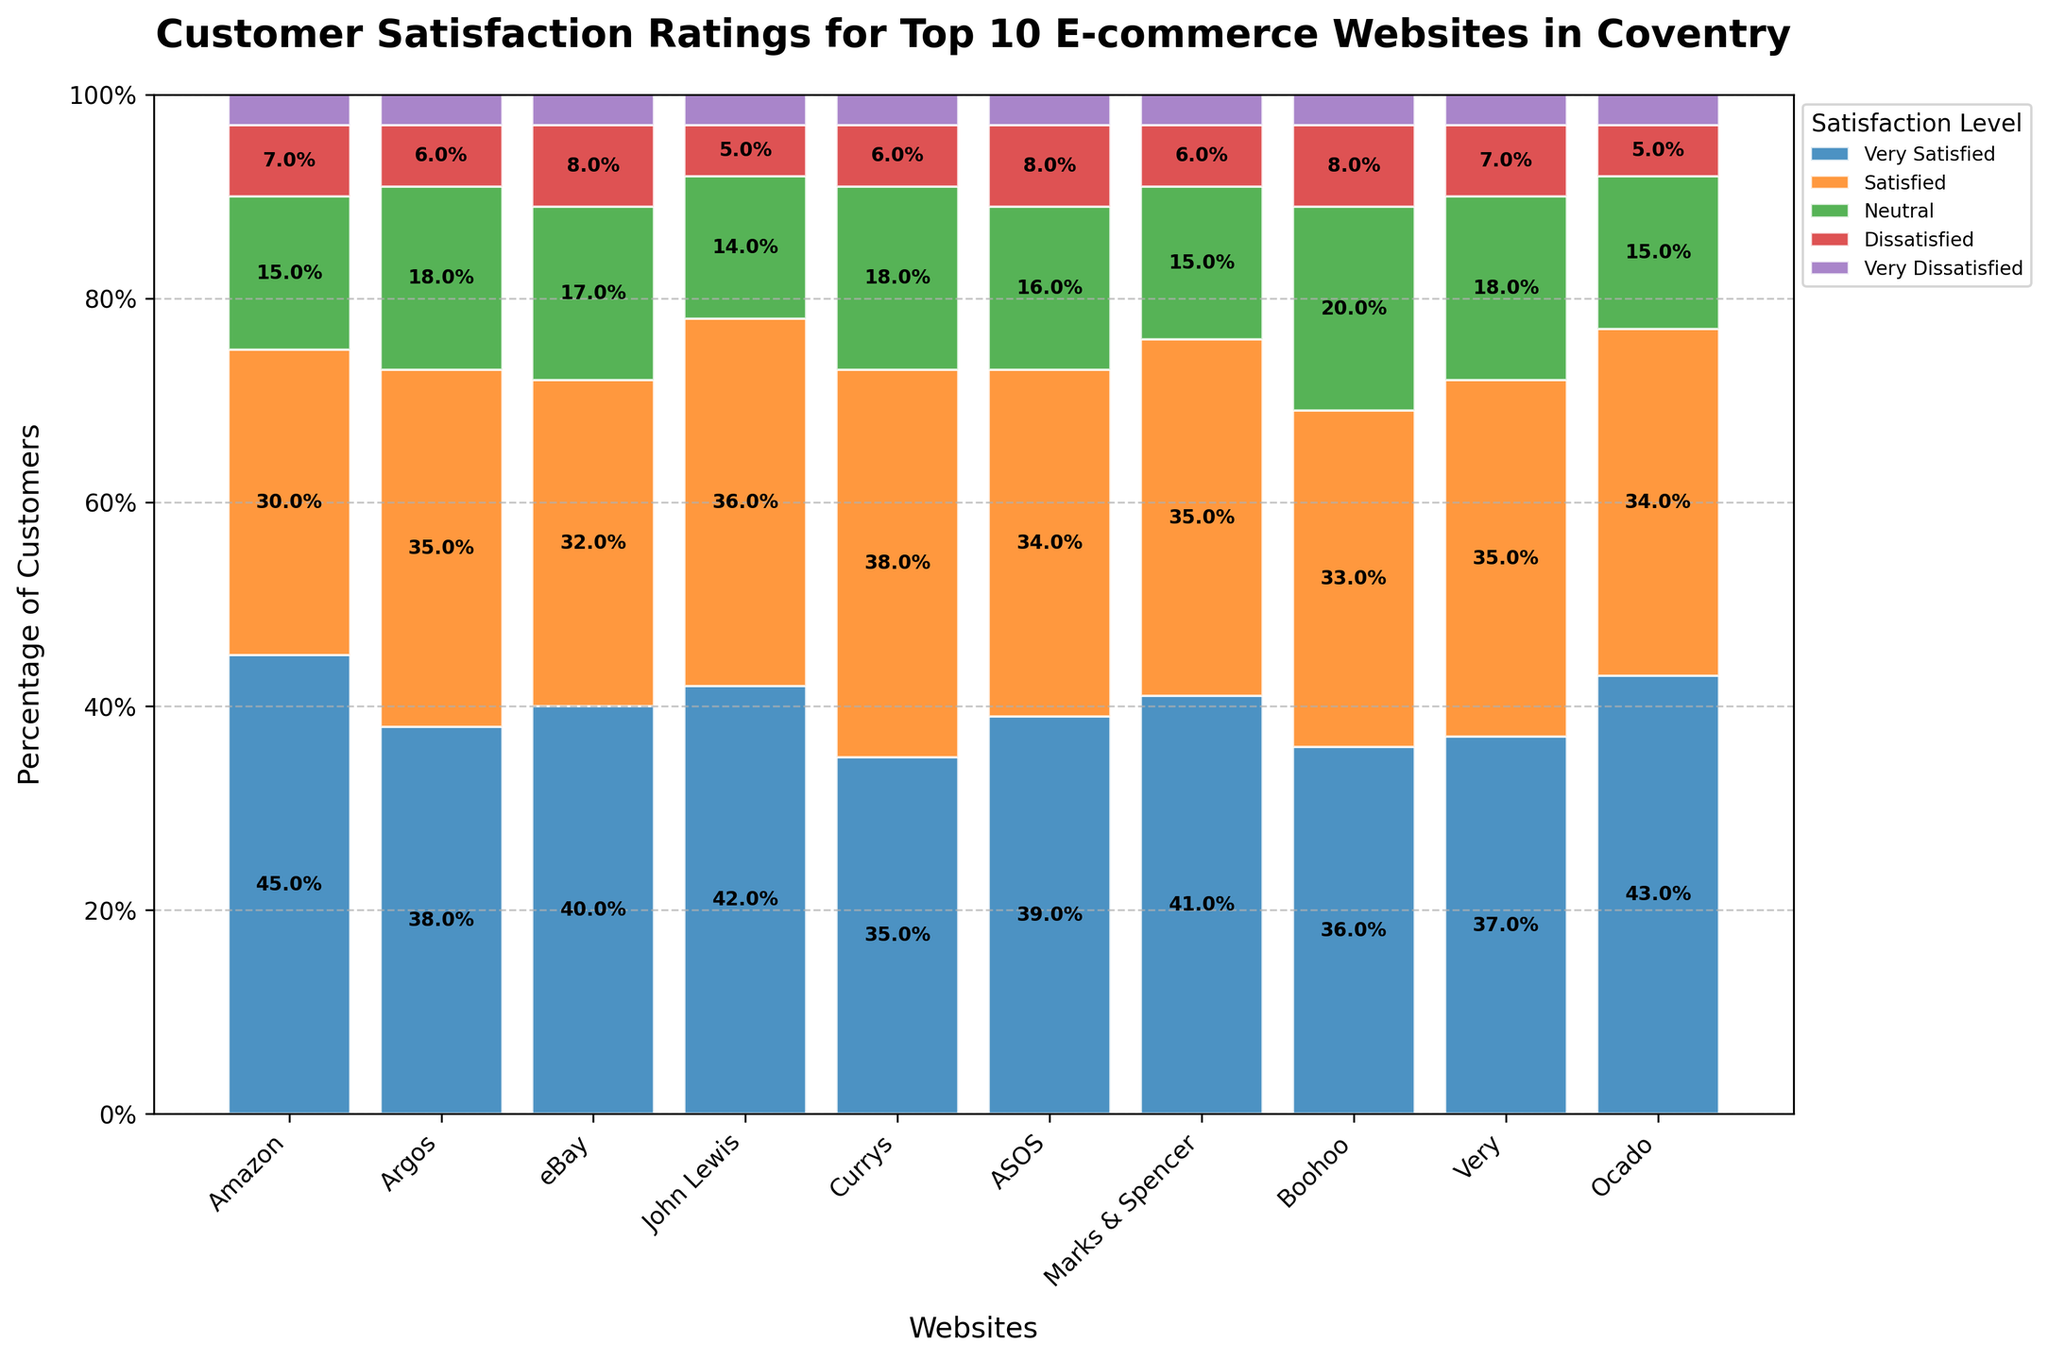Which website received the highest percentage of 'Very Satisfied' customers? Looking at the 'Very Satisfied' segment (likely the topmost segment in each bar), Amazon has the highest percentage.
Answer: Amazon Which website received the lowest percentage of 'Neutral' customers? By examining the 'Neutral' segment (likely the middle segment in the bars), John Lewis has the lowest percentage.
Answer: John Lewis What's the difference in the percentage of 'Very Satisfied' customers between Amazon and Currys? For Amazon, 'Very Satisfied' is 45%. For Currys, it's 35%. The difference is 45% - 35% = 10%.
Answer: 10% How do the satisfaction ratings of Ocado compare to those of Argos? For Ocado: 'Very Satisfied' is 43%, 'Satisfied' is 34%, 'Neutral' is 15%, 'Dissatisfied' is 5%, 'Very Dissatisfied' is 3%. For Argos: 'Very Satisfied' is 38%, 'Satisfied' is 35%, 'Neutral' is 18%, 'Dissatisfied' is 6%, 'Very Dissatisfied' is 3%. Ocado has higher 'Very Satisfied', but lower 'Satisfied' and 'Neutral' percentages compared to Argos.
Answer: Ocado has higher 'Very Satisfied' percentage but lower 'Satisfied' and 'Neutral' percentages Which two websites have the closest percentages of 'Dissatisfied' customers? By checking the 'Dissatisfied' segments, Amazon, Argos, and Currys all have a 'Dissatisfied' percentage of 7%, meaning the pair of Argos and Currys are the closest.
Answer: Argos and Currys What's the average percentage of 'Satisfied' customers across all websites? Summing the 'Satisfied' percentages: 30 + 35 + 32 + 36 + 38 + 34 + 35 + 33 + 35 + 34 = 342. Dividing by 10: 342 / 10 = 34.2%.
Answer: 34.2% Which website has the highest combined percentage of 'Very Satisfied' and 'Satisfied' customers, and what is that percentage? Summing 'Very Satisfied' and 'Satisfied' for each website, John Lewis tops with 42% + 36% = 78%.
Answer: John Lewis, 78% How many websites have a 'Very Dissatisfied' percentage of exactly 3%? Checking the 'Very Dissatisfied' segment, all websites except for one have exactly 3% 'Very Dissatisfied'. So, 9 websites meet the criteria.
Answer: 9 If you sum up the 'Neutral' percentages of Amazon, eBay, and ASOS, what do you get? Adding the 'Neutral' percentages of Amazon (15%), eBay (17%), and ASOS (16%): 15 + 17 + 16 = 48%.
Answer: 48% What is the total percentage of 'Dissatisfied' and 'Very Dissatisfied' customers for Boohoo? The 'Dissatisfied' percentage is 8% and the 'Very Dissatisfied' is 3%. Adding these: 8% + 3% = 11%.
Answer: 11% 